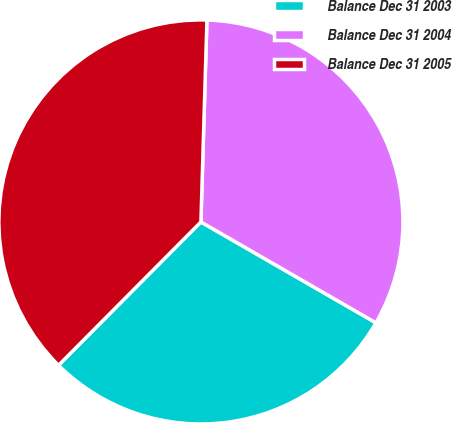Convert chart. <chart><loc_0><loc_0><loc_500><loc_500><pie_chart><fcel>Balance Dec 31 2003<fcel>Balance Dec 31 2004<fcel>Balance Dec 31 2005<nl><fcel>29.13%<fcel>32.85%<fcel>38.03%<nl></chart> 